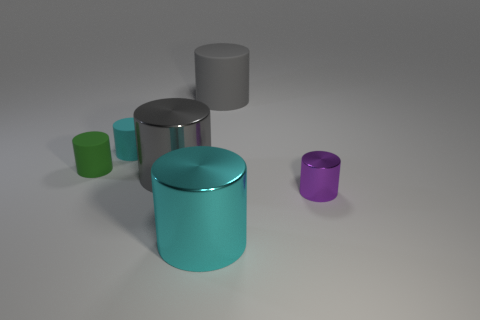Can you guess the purpose of these objects? Without additional context, it's speculative, but these objects might be decorative or could be part of a product display. Their simple geometric shapes suggest they might also be used for a graphical rendering or 3D modeling exercise. 